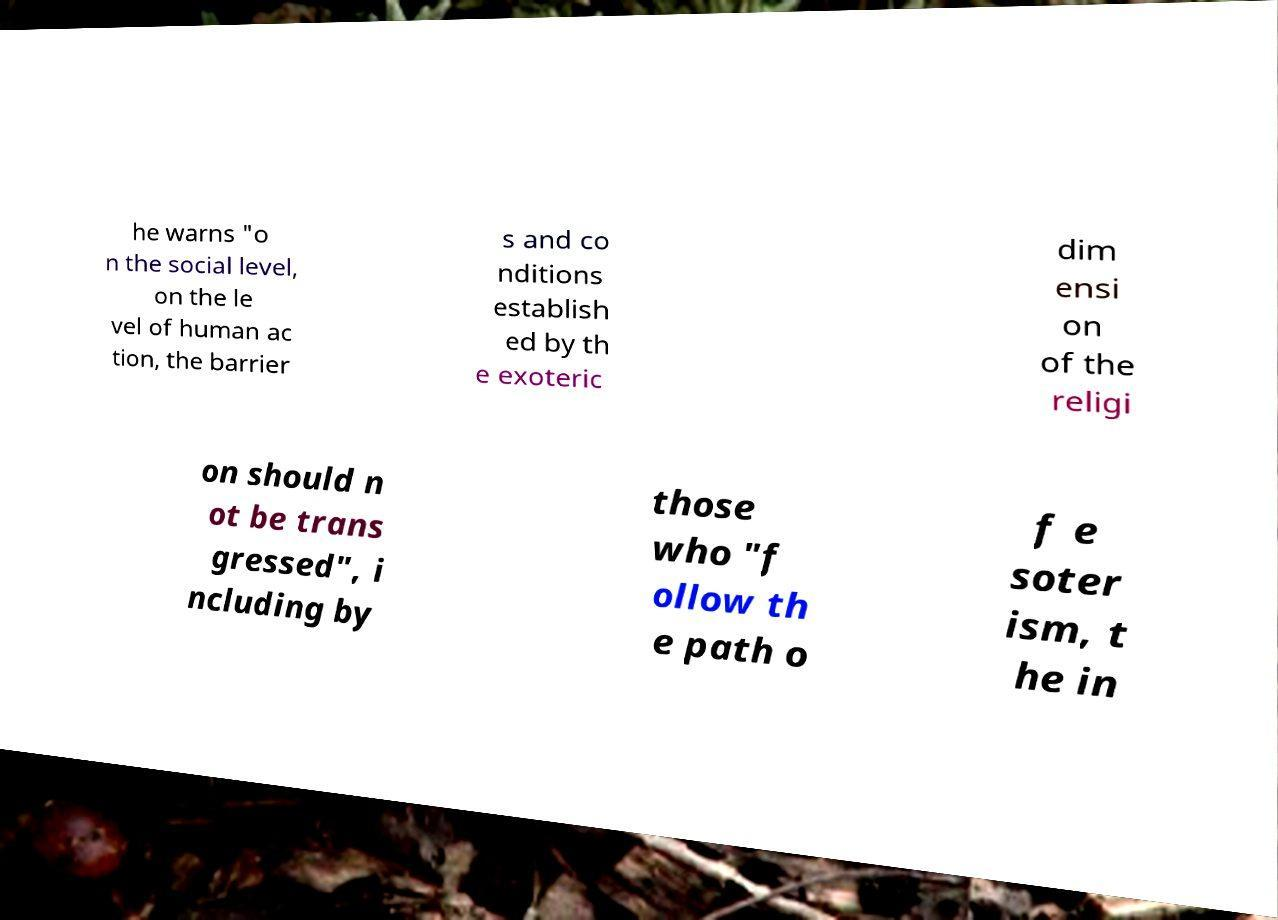Please read and relay the text visible in this image. What does it say? he warns "o n the social level, on the le vel of human ac tion, the barrier s and co nditions establish ed by th e exoteric dim ensi on of the religi on should n ot be trans gressed", i ncluding by those who "f ollow th e path o f e soter ism, t he in 